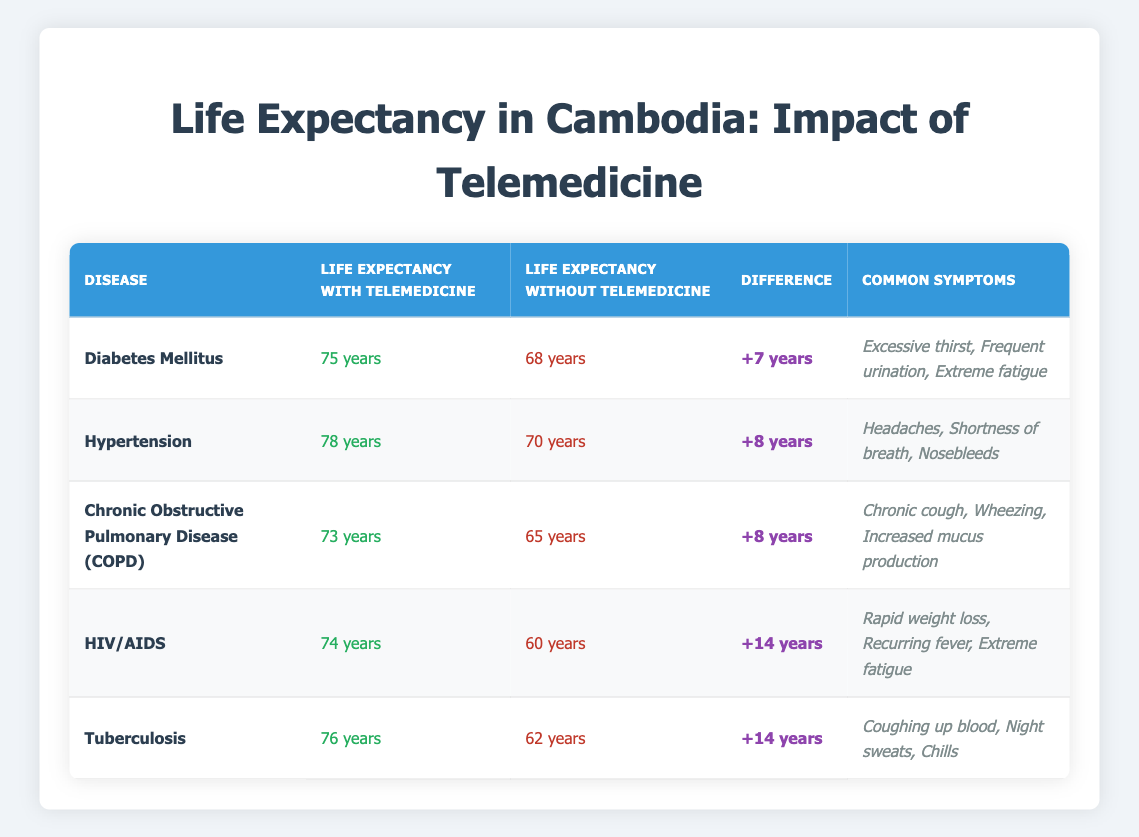What is the life expectancy for Diabetes Mellitus with telemedicine? According to the table, the life expectancy for Diabetes Mellitus with telemedicine is listed as 75 years.
Answer: 75 years What is the difference in life expectancy for HIV/AIDS with and without telemedicine? The life expectancy with telemedicine for HIV/AIDS is 74 years, and without is 60 years. The difference is calculated as 74 - 60 = 14 years.
Answer: 14 years Does the life expectancy increase for all diseases when telemedicine is implemented? By examining each row in the table, we can confirm that life expectancy increases when telemedicine is used across all diseases listed.
Answer: Yes Which disease has the highest life expectancy without telemedicine? Checking the table, the disease with the highest life expectancy without telemedicine is Hypertension, which is at 70 years.
Answer: Hypertension What is the total increase in life expectancy when telemedicine is applied across all diseases? The increases are: Diabetes Mellitus (+7), Hypertension (+8), COPD (+8), HIV/AIDS (+14), and Tuberculosis (+14). Summing these gives 7 + 8 + 8 + 14 + 14 = 51 years total increase.
Answer: 51 years Is the life expectancy for Chronic Obstructive Pulmonary Disease higher with telemedicine than for Diabetes Mellitus without telemedicine? The life expectancy for COPD with telemedicine is 73 years, while for Diabetes Mellitus without telemedicine it is 68 years. Since 73 > 68, the statement is true.
Answer: Yes What is the average life expectancy with telemedicine for the listed diseases? The life expectancies with telemedicine are 75, 78, 73, 74, and 76 years. Adding these gives 376 years, and dividing by 5 (the number of diseases) results in an average of 75.2 years.
Answer: 75.2 years How many common symptoms are listed for Tuberculosis? The table provides three common symptoms for Tuberculosis: "Coughing up blood," "Night sweats," and "Chills." Counting these gives a total of three symptoms.
Answer: 3 symptoms Which disease benefits the most in terms of increased life expectancy when telemedicine is used? By comparing the differences, HIV/AIDS and Tuberculosis both show a difference of 14 years, which is the highest among the listed diseases.
Answer: HIV/AIDS and Tuberculosis 